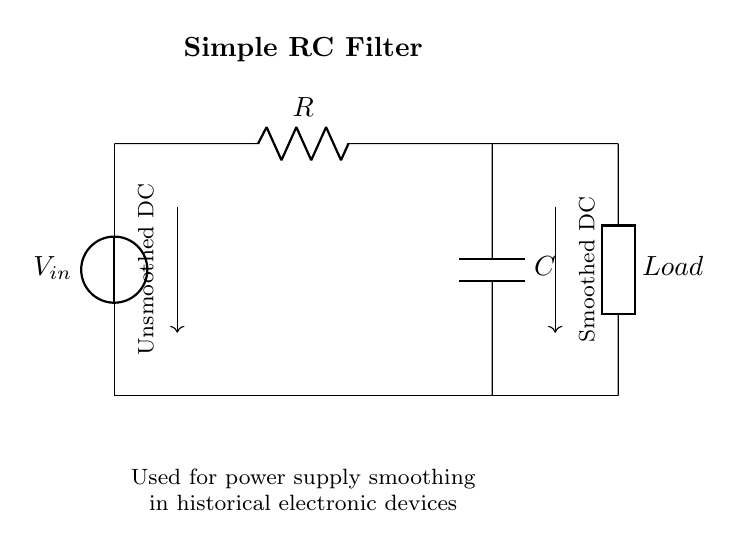What is the main purpose of this circuit? The main purpose of the circuit is to smooth the power supply by filtering out ripples from the unsmoothed DC voltage. This is achieved through the combination of the resistor and capacitor in an RC filter configuration.
Answer: power supply smoothing What component is used to store charge in this circuit? The capacitor is the component used to store charge. In the RC filter, it charges when the voltage rises and discharges when the voltage drops, thus providing a more stable output voltage.
Answer: Capacitor How many components are present in the circuit? The circuit contains three main components: a voltage source, a resistor, and a capacitor. Additionally, there is a load connected, but in terms of active components used for filtering, only the resistor and capacitor are counted.
Answer: Three What type of filter is represented in this circuit? This circuit is an RC low-pass filter. A low-pass filter allows low-frequency signals to pass through while attenuating high-frequency signals, making it suitable for smoothing applications.
Answer: RC low-pass filter What signal is emitted from the load? The load emits a smoothed DC signal as a result of the filtering process carried out by the RC components. The signal is expected to have significantly reduced voltage ripples compared to the unsmoothed input.
Answer: Smoothed DC What happens to the voltage across the capacitor when the input voltage is higher? When the input voltage is higher, the voltage across the capacitor increases as it charges up towards the input voltage level. This charging process helps in reducing voltage fluctuations and provides stability in the output.
Answer: Increases What is the role of the resistor in this filter circuit? The resistor limits the charging and discharging rate of the capacitor, thus influencing the time constant of the filter circuit, which determines how quickly the capacitor can respond to changes in the input voltage.
Answer: Limits charging rate 